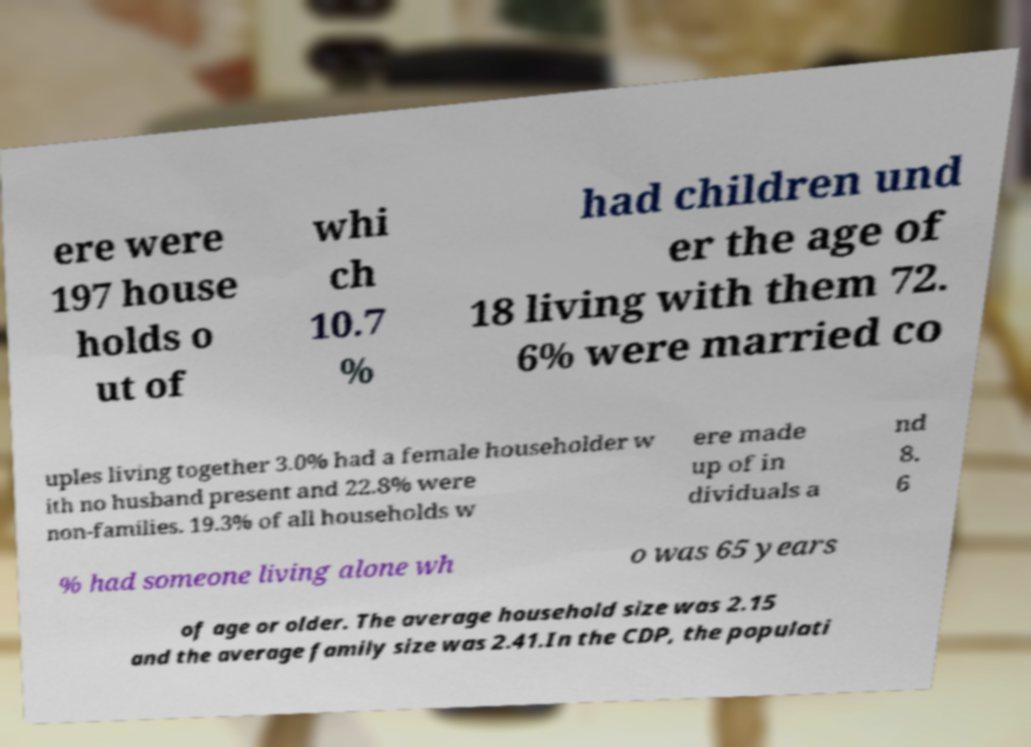What messages or text are displayed in this image? I need them in a readable, typed format. ere were 197 house holds o ut of whi ch 10.7 % had children und er the age of 18 living with them 72. 6% were married co uples living together 3.0% had a female householder w ith no husband present and 22.8% were non-families. 19.3% of all households w ere made up of in dividuals a nd 8. 6 % had someone living alone wh o was 65 years of age or older. The average household size was 2.15 and the average family size was 2.41.In the CDP, the populati 